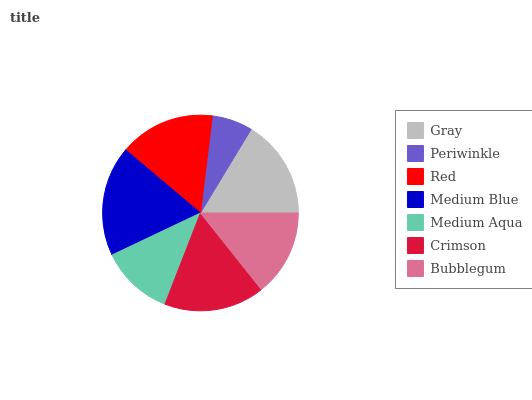Is Periwinkle the minimum?
Answer yes or no. Yes. Is Medium Blue the maximum?
Answer yes or no. Yes. Is Red the minimum?
Answer yes or no. No. Is Red the maximum?
Answer yes or no. No. Is Red greater than Periwinkle?
Answer yes or no. Yes. Is Periwinkle less than Red?
Answer yes or no. Yes. Is Periwinkle greater than Red?
Answer yes or no. No. Is Red less than Periwinkle?
Answer yes or no. No. Is Red the high median?
Answer yes or no. Yes. Is Red the low median?
Answer yes or no. Yes. Is Medium Aqua the high median?
Answer yes or no. No. Is Crimson the low median?
Answer yes or no. No. 